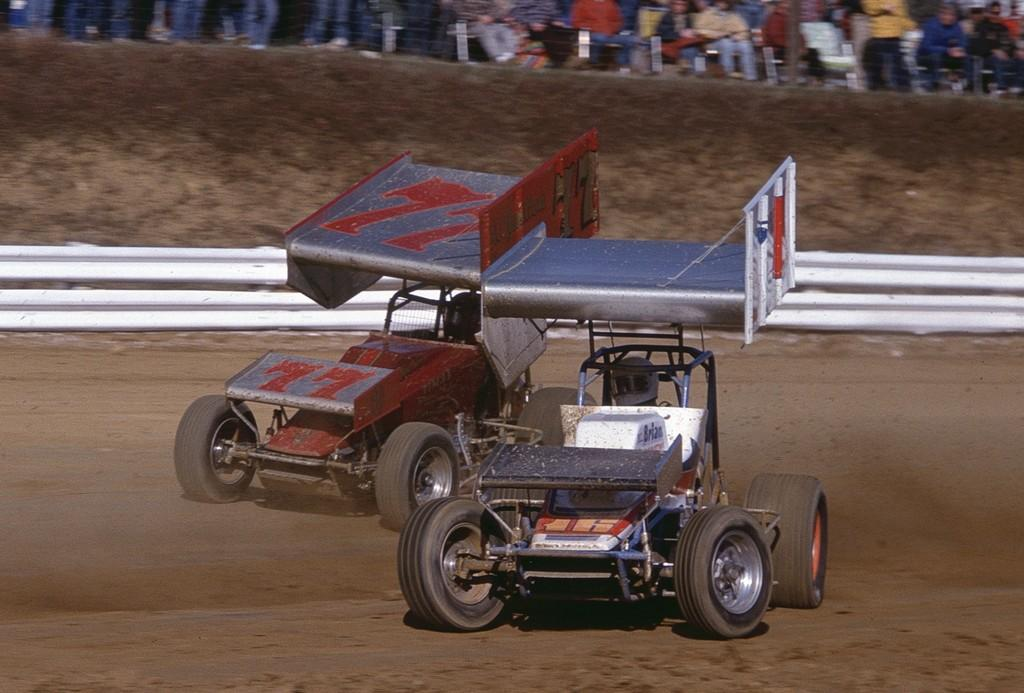What is the main subject in the center of the image? There are vehicles in the center of the image. What can be seen in the background of the image? There is a crowd in the background of the image. What type of needle is being used by the person in the image? There is no person or needle present in the image; it features vehicles and a crowd in the background. 